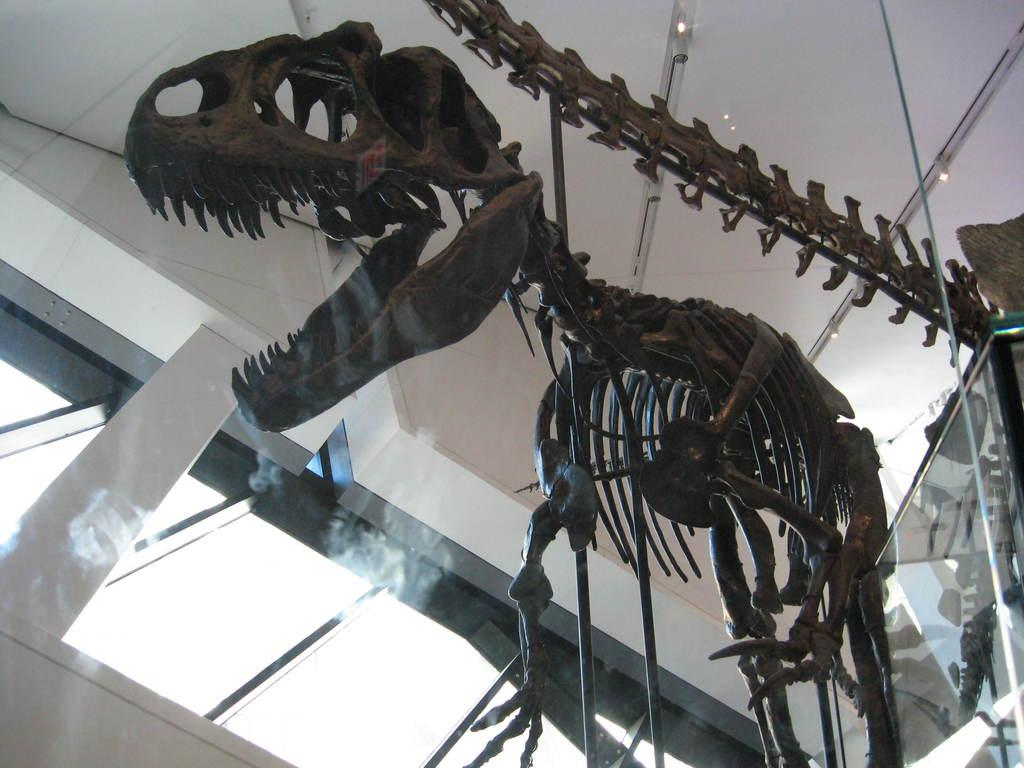What type of statue is in the image? The statue is of a dinosaur. What material is the statue made of? The statue is made of bone. Where is the statue located? The statue is kept in a building. What type of quilt is draped over the dinosaur statue in the image? There is no quilt present in the image; it features a dinosaur bone statue in a building. 